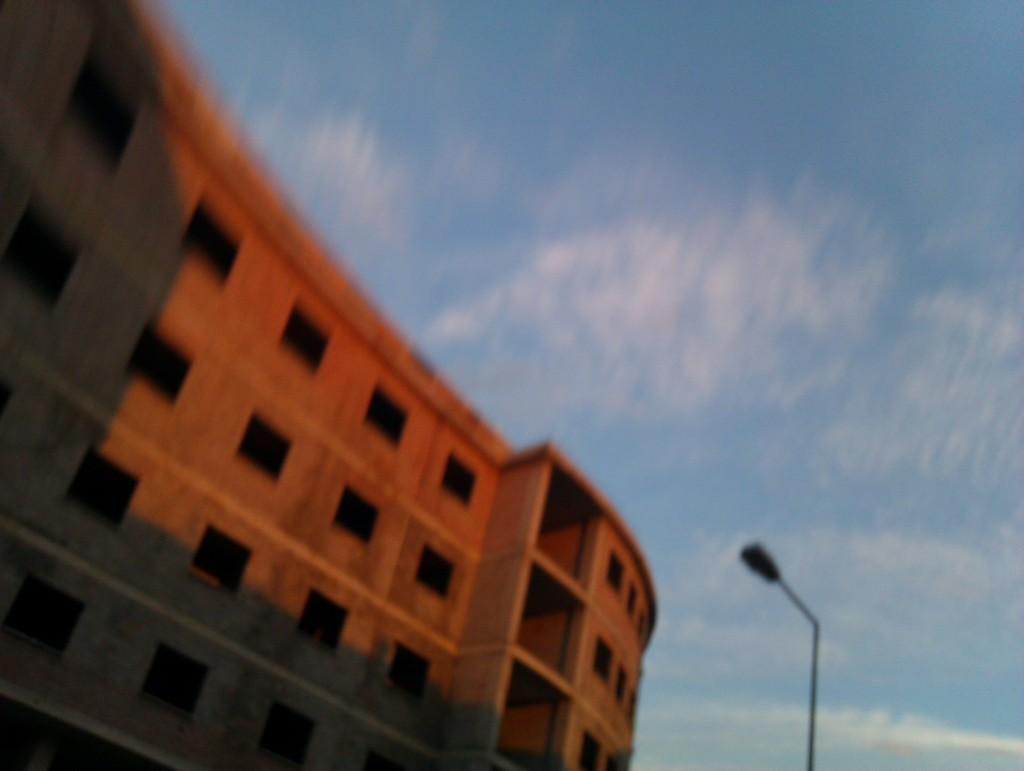What type of structure is present in the image? There is a building in the image. What can be seen on the right side of the image? There is a pole on the right side of the image. What is visible in the background of the image? The sky is visible in the background of the image. What type of wrist accessory is visible on the building in the image? There is no wrist accessory present on the building in the image. What part of the quince plant can be seen growing on the pole in the image? There is no quince plant or any part of it present in the image. 